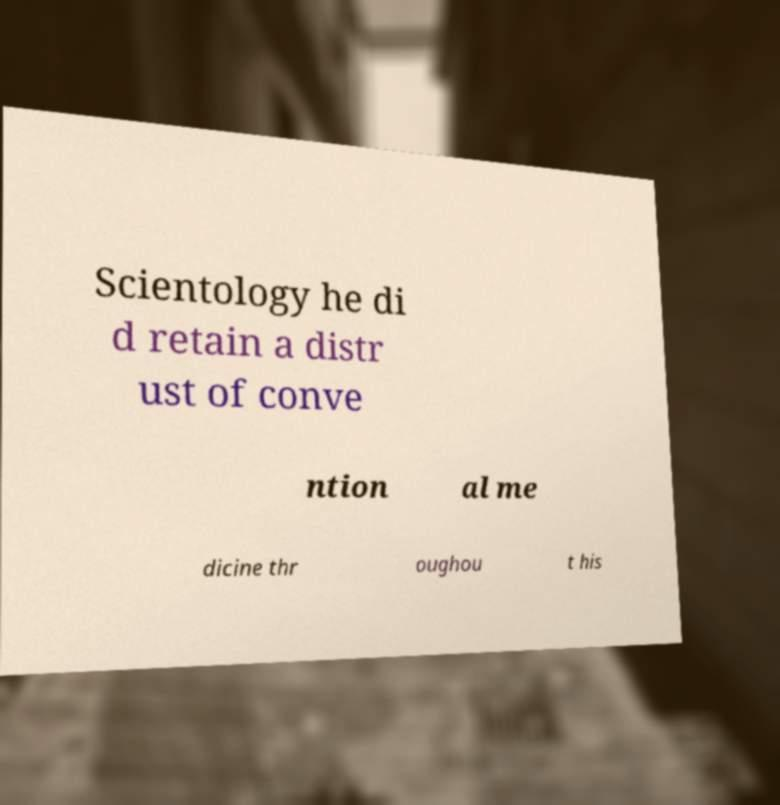Can you read and provide the text displayed in the image?This photo seems to have some interesting text. Can you extract and type it out for me? Scientology he di d retain a distr ust of conve ntion al me dicine thr oughou t his 